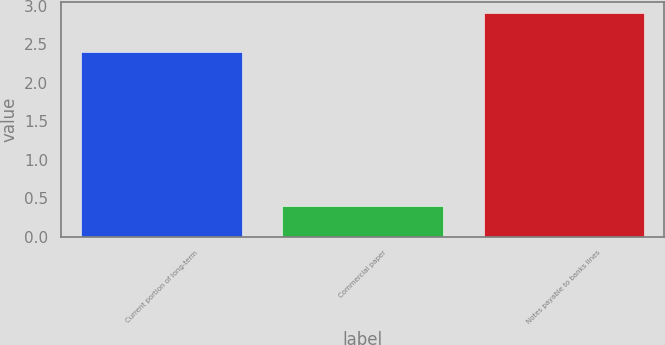Convert chart to OTSL. <chart><loc_0><loc_0><loc_500><loc_500><bar_chart><fcel>Current portion of long-term<fcel>Commercial paper<fcel>Notes payable to banks lines<nl><fcel>2.4<fcel>0.4<fcel>2.9<nl></chart> 